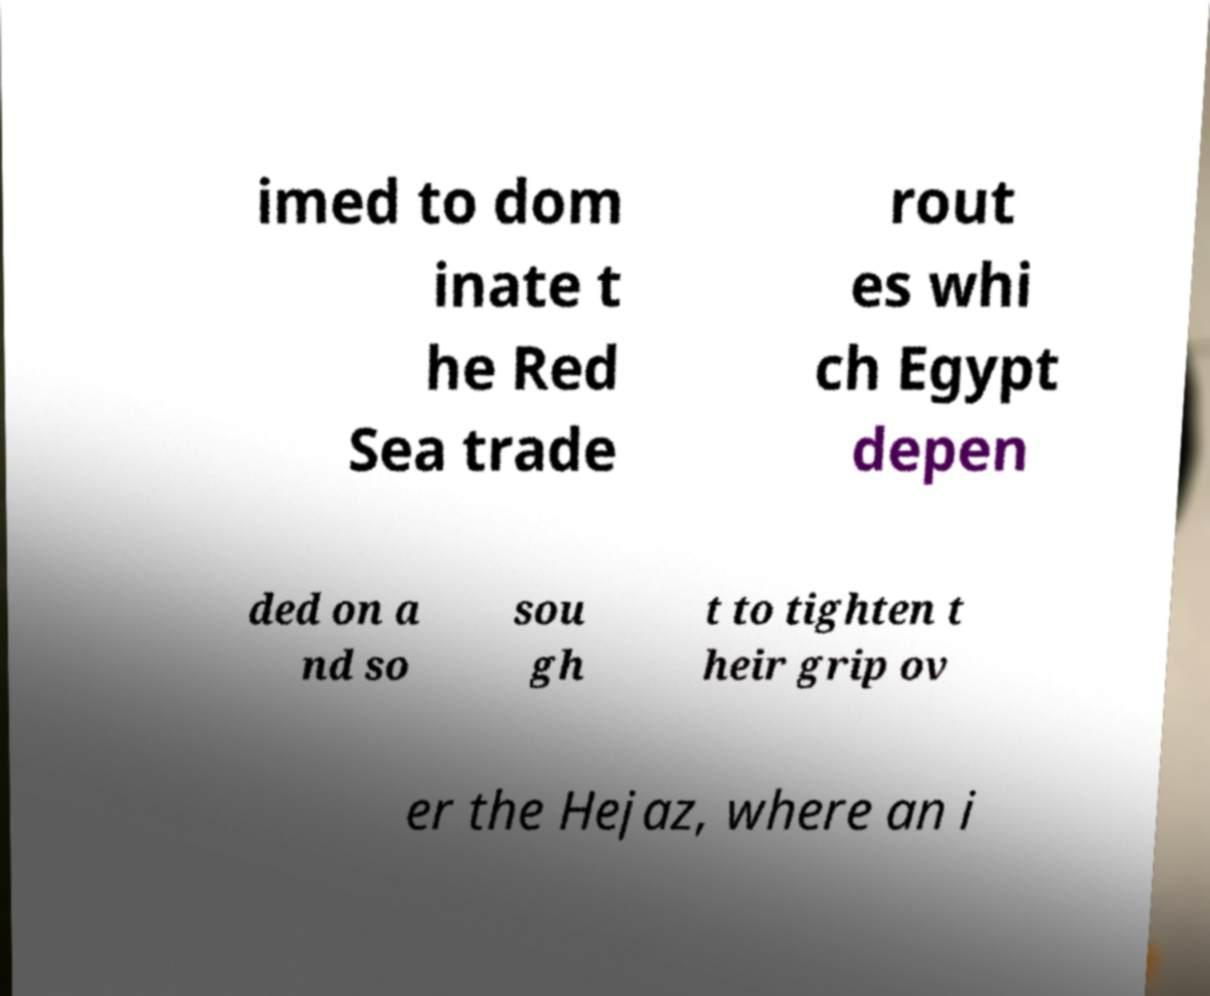What messages or text are displayed in this image? I need them in a readable, typed format. imed to dom inate t he Red Sea trade rout es whi ch Egypt depen ded on a nd so sou gh t to tighten t heir grip ov er the Hejaz, where an i 